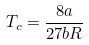Convert formula to latex. <formula><loc_0><loc_0><loc_500><loc_500>T _ { c } = \frac { 8 a } { 2 7 b R }</formula> 